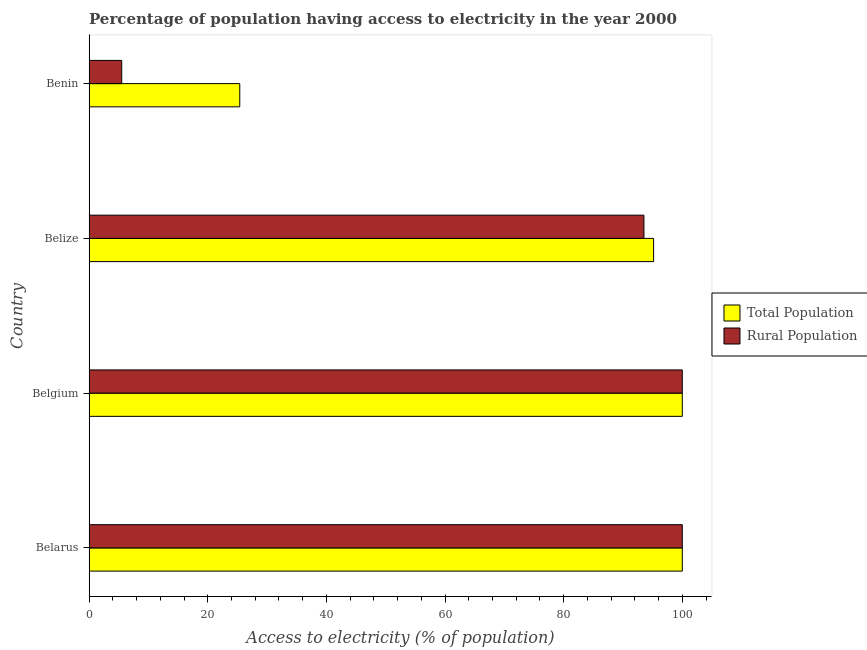How many different coloured bars are there?
Your response must be concise. 2. How many groups of bars are there?
Provide a succinct answer. 4. Are the number of bars per tick equal to the number of legend labels?
Offer a very short reply. Yes. Are the number of bars on each tick of the Y-axis equal?
Keep it short and to the point. Yes. How many bars are there on the 4th tick from the top?
Your answer should be very brief. 2. How many bars are there on the 4th tick from the bottom?
Provide a succinct answer. 2. What is the label of the 2nd group of bars from the top?
Your answer should be compact. Belize. In how many cases, is the number of bars for a given country not equal to the number of legend labels?
Provide a short and direct response. 0. What is the percentage of population having access to electricity in Belarus?
Ensure brevity in your answer.  100. Across all countries, what is the minimum percentage of population having access to electricity?
Your response must be concise. 25.4. In which country was the percentage of population having access to electricity maximum?
Keep it short and to the point. Belarus. In which country was the percentage of population having access to electricity minimum?
Provide a short and direct response. Benin. What is the total percentage of rural population having access to electricity in the graph?
Provide a succinct answer. 299.03. What is the difference between the percentage of rural population having access to electricity in Belize and that in Benin?
Your answer should be very brief. 88.03. What is the difference between the percentage of population having access to electricity in Belgium and the percentage of rural population having access to electricity in Belize?
Give a very brief answer. 6.47. What is the average percentage of rural population having access to electricity per country?
Give a very brief answer. 74.76. What is the difference between the percentage of population having access to electricity and percentage of rural population having access to electricity in Belize?
Ensure brevity in your answer.  1.63. In how many countries, is the percentage of population having access to electricity greater than 100 %?
Give a very brief answer. 0. What is the ratio of the percentage of rural population having access to electricity in Belarus to that in Benin?
Your answer should be very brief. 18.18. Is the difference between the percentage of rural population having access to electricity in Belarus and Benin greater than the difference between the percentage of population having access to electricity in Belarus and Benin?
Ensure brevity in your answer.  Yes. What is the difference between the highest and the second highest percentage of rural population having access to electricity?
Offer a terse response. 0. What is the difference between the highest and the lowest percentage of population having access to electricity?
Your response must be concise. 74.6. Is the sum of the percentage of population having access to electricity in Belarus and Belgium greater than the maximum percentage of rural population having access to electricity across all countries?
Your answer should be very brief. Yes. What does the 1st bar from the top in Belize represents?
Offer a very short reply. Rural Population. What does the 1st bar from the bottom in Belarus represents?
Provide a short and direct response. Total Population. Are all the bars in the graph horizontal?
Make the answer very short. Yes. How many countries are there in the graph?
Your answer should be very brief. 4. What is the difference between two consecutive major ticks on the X-axis?
Your answer should be very brief. 20. Does the graph contain any zero values?
Make the answer very short. No. Does the graph contain grids?
Your response must be concise. No. Where does the legend appear in the graph?
Offer a very short reply. Center right. How many legend labels are there?
Your response must be concise. 2. What is the title of the graph?
Provide a short and direct response. Percentage of population having access to electricity in the year 2000. Does "Technicians" appear as one of the legend labels in the graph?
Provide a succinct answer. No. What is the label or title of the X-axis?
Give a very brief answer. Access to electricity (% of population). What is the Access to electricity (% of population) in Total Population in Belarus?
Ensure brevity in your answer.  100. What is the Access to electricity (% of population) in Rural Population in Belarus?
Keep it short and to the point. 100. What is the Access to electricity (% of population) in Rural Population in Belgium?
Offer a terse response. 100. What is the Access to electricity (% of population) in Total Population in Belize?
Offer a terse response. 95.16. What is the Access to electricity (% of population) of Rural Population in Belize?
Your answer should be compact. 93.53. What is the Access to electricity (% of population) of Total Population in Benin?
Your answer should be very brief. 25.4. Across all countries, what is the maximum Access to electricity (% of population) in Total Population?
Offer a very short reply. 100. Across all countries, what is the minimum Access to electricity (% of population) in Total Population?
Your answer should be compact. 25.4. What is the total Access to electricity (% of population) of Total Population in the graph?
Your answer should be very brief. 320.56. What is the total Access to electricity (% of population) in Rural Population in the graph?
Ensure brevity in your answer.  299.03. What is the difference between the Access to electricity (% of population) of Rural Population in Belarus and that in Belgium?
Your answer should be compact. 0. What is the difference between the Access to electricity (% of population) of Total Population in Belarus and that in Belize?
Offer a very short reply. 4.84. What is the difference between the Access to electricity (% of population) in Rural Population in Belarus and that in Belize?
Your answer should be very brief. 6.47. What is the difference between the Access to electricity (% of population) in Total Population in Belarus and that in Benin?
Give a very brief answer. 74.6. What is the difference between the Access to electricity (% of population) in Rural Population in Belarus and that in Benin?
Provide a short and direct response. 94.5. What is the difference between the Access to electricity (% of population) in Total Population in Belgium and that in Belize?
Offer a terse response. 4.84. What is the difference between the Access to electricity (% of population) in Rural Population in Belgium and that in Belize?
Your answer should be compact. 6.47. What is the difference between the Access to electricity (% of population) in Total Population in Belgium and that in Benin?
Your response must be concise. 74.6. What is the difference between the Access to electricity (% of population) in Rural Population in Belgium and that in Benin?
Your answer should be compact. 94.5. What is the difference between the Access to electricity (% of population) in Total Population in Belize and that in Benin?
Make the answer very short. 69.76. What is the difference between the Access to electricity (% of population) of Rural Population in Belize and that in Benin?
Offer a terse response. 88.03. What is the difference between the Access to electricity (% of population) in Total Population in Belarus and the Access to electricity (% of population) in Rural Population in Belize?
Make the answer very short. 6.47. What is the difference between the Access to electricity (% of population) of Total Population in Belarus and the Access to electricity (% of population) of Rural Population in Benin?
Ensure brevity in your answer.  94.5. What is the difference between the Access to electricity (% of population) in Total Population in Belgium and the Access to electricity (% of population) in Rural Population in Belize?
Offer a very short reply. 6.47. What is the difference between the Access to electricity (% of population) of Total Population in Belgium and the Access to electricity (% of population) of Rural Population in Benin?
Make the answer very short. 94.5. What is the difference between the Access to electricity (% of population) of Total Population in Belize and the Access to electricity (% of population) of Rural Population in Benin?
Give a very brief answer. 89.66. What is the average Access to electricity (% of population) in Total Population per country?
Your response must be concise. 80.14. What is the average Access to electricity (% of population) in Rural Population per country?
Provide a short and direct response. 74.76. What is the difference between the Access to electricity (% of population) in Total Population and Access to electricity (% of population) in Rural Population in Belarus?
Your answer should be compact. 0. What is the difference between the Access to electricity (% of population) in Total Population and Access to electricity (% of population) in Rural Population in Belize?
Ensure brevity in your answer.  1.63. What is the ratio of the Access to electricity (% of population) of Rural Population in Belarus to that in Belgium?
Your response must be concise. 1. What is the ratio of the Access to electricity (% of population) in Total Population in Belarus to that in Belize?
Give a very brief answer. 1.05. What is the ratio of the Access to electricity (% of population) of Rural Population in Belarus to that in Belize?
Your answer should be compact. 1.07. What is the ratio of the Access to electricity (% of population) in Total Population in Belarus to that in Benin?
Make the answer very short. 3.94. What is the ratio of the Access to electricity (% of population) of Rural Population in Belarus to that in Benin?
Your answer should be compact. 18.18. What is the ratio of the Access to electricity (% of population) in Total Population in Belgium to that in Belize?
Make the answer very short. 1.05. What is the ratio of the Access to electricity (% of population) in Rural Population in Belgium to that in Belize?
Your answer should be compact. 1.07. What is the ratio of the Access to electricity (% of population) of Total Population in Belgium to that in Benin?
Keep it short and to the point. 3.94. What is the ratio of the Access to electricity (% of population) in Rural Population in Belgium to that in Benin?
Offer a very short reply. 18.18. What is the ratio of the Access to electricity (% of population) of Total Population in Belize to that in Benin?
Ensure brevity in your answer.  3.75. What is the ratio of the Access to electricity (% of population) in Rural Population in Belize to that in Benin?
Offer a very short reply. 17.01. What is the difference between the highest and the lowest Access to electricity (% of population) in Total Population?
Your answer should be very brief. 74.6. What is the difference between the highest and the lowest Access to electricity (% of population) in Rural Population?
Your answer should be compact. 94.5. 